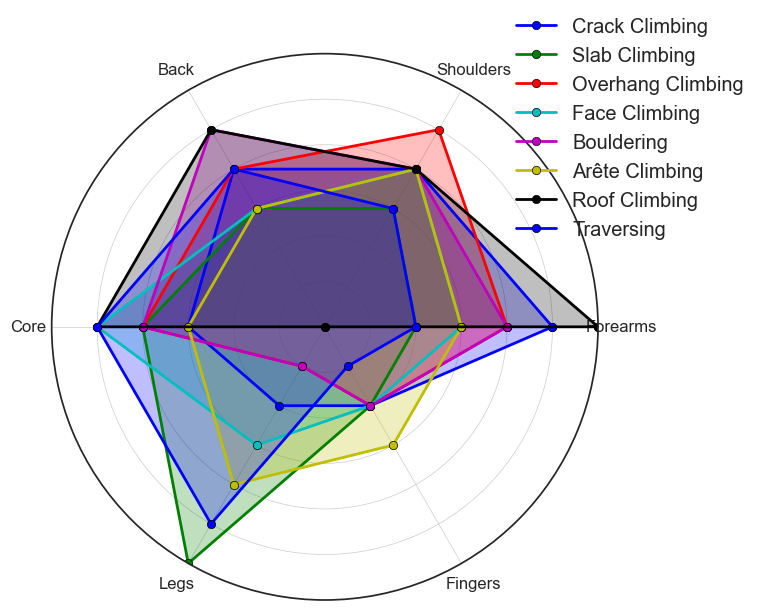Which climbing technique utilizes the highest percentage of the core muscle group? Looking at the figure, identify the technique with the highest data point on the core axis.
Answer: Face Climbing What is the difference in the percentage of leg usage between Crack Climbing and Slab Climbing? Find the data points for leg usage in both techniques and subtract the Crack Climbing value from the Slab Climbing value (30 - 10).
Answer: 20 Which climbing technique has the smallest range of muscle group percentages? Determine the range (maximum minus minimum) for each technique and identify the one with the smallest range. Slab Climbing has the smallest range with values from 10 to 30.
Answer: Slab Climbing What is the average percentage of forearm usage across all climbing techniques? Sum up all forearm usage values and divide by the number of techniques. Calculations: (25 + 10 + 20 + 15 + 20 + 15 + 30 + 10) / 8 = 18.125.
Answer: 18.125 Which two climbing techniques have the same percentage of finger usage? Compare the finger usage values for all techniques and identify the two with identical values. Both Crack Climbing and Slab Climbing have 10% usage.
Answer: Crack Climbing and Slab Climbing In which climbing technique is the usage of legs exactly three times that of fingers? Identify the technique where the leg value is 3 times the finger value. For Arête Climbing, legs are 20 and fingers are 15, which doesn't satisfy the condition. For Slab Climbing, legs are 30 and fingers are 10, which meets the condition.
Answer: Slab Climbing Which muscle group has the highest overall average usage across all climbing techniques? Calculate the average usage for each muscle group across all techniques. Summarized, Core (20). Core has the highest average.
Answer: Core Between Overhang Climbing and Bouldering, which technique utilizes the back muscles more? Compare the data points for back usage in both techniques. Overhang Climbing has 20%, and Bouldering has 25%.
Answer: Bouldering What is the percentage difference in shoulder muscle usage between Face Climbing and Roof Climbing? Subtract the shoulder usage in Face Climbing from Roof Climbing (20 - 20 = 0).
Answer: 0 Which climbing technique requires equally distributed muscle effort among forearms, back, and shoulders? Identify the technique with approximately equal values for forearms, back, and shoulders. Both Overhang Climbing and Bouldering have close values around 20-25%.
Answer: Overhang Climbing 